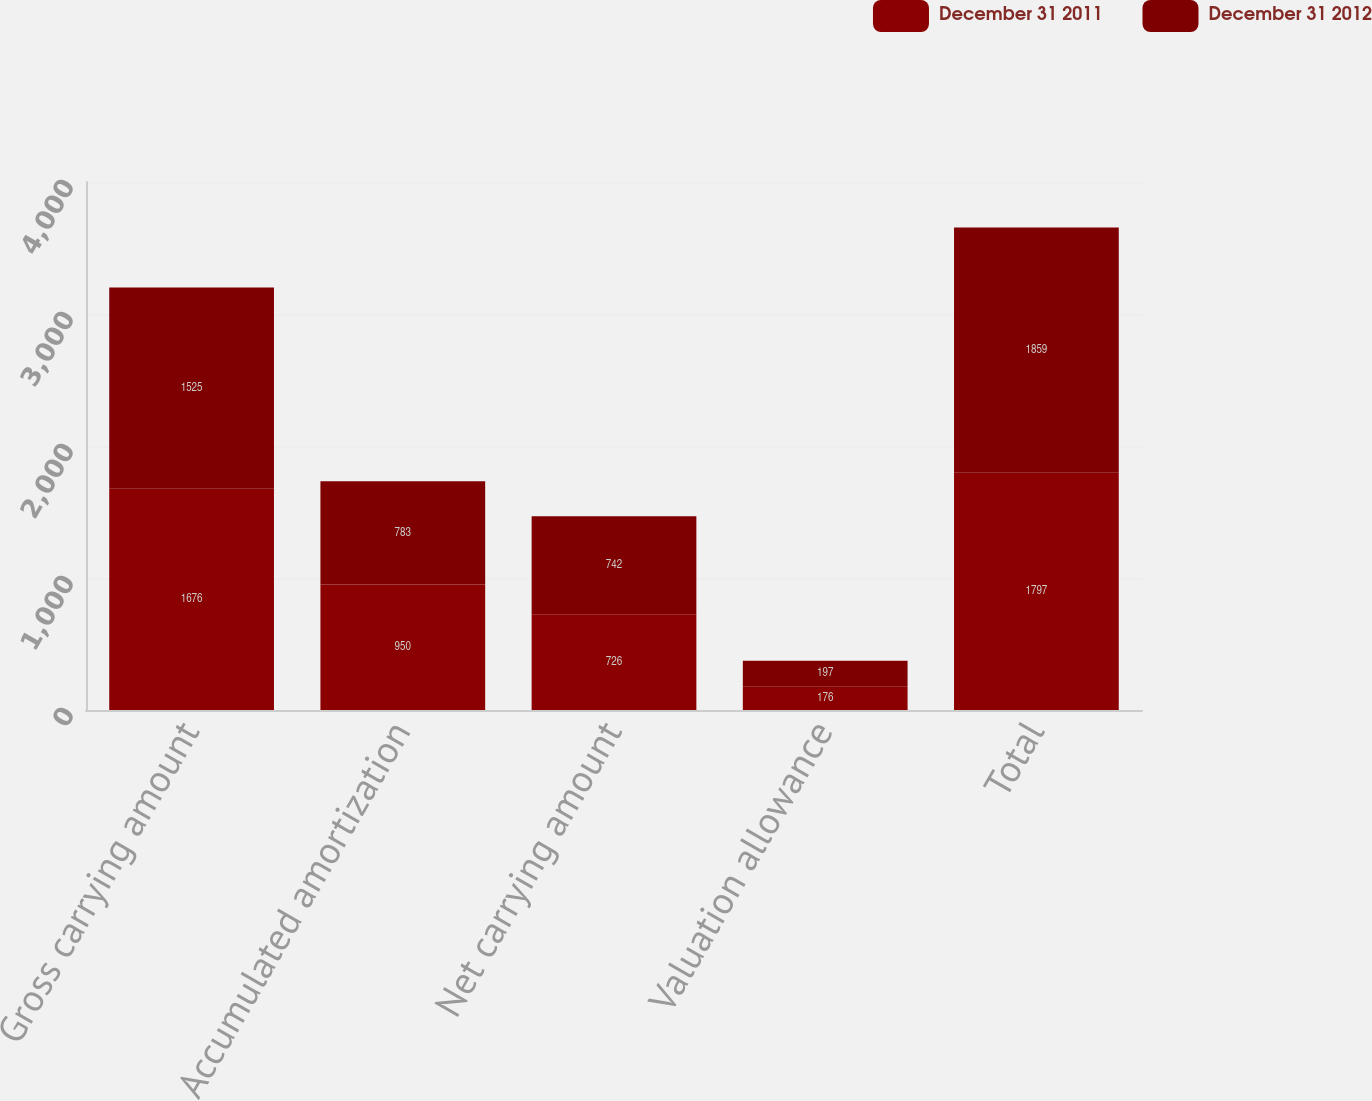<chart> <loc_0><loc_0><loc_500><loc_500><stacked_bar_chart><ecel><fcel>Gross carrying amount<fcel>Accumulated amortization<fcel>Net carrying amount<fcel>Valuation allowance<fcel>Total<nl><fcel>December 31 2011<fcel>1676<fcel>950<fcel>726<fcel>176<fcel>1797<nl><fcel>December 31 2012<fcel>1525<fcel>783<fcel>742<fcel>197<fcel>1859<nl></chart> 